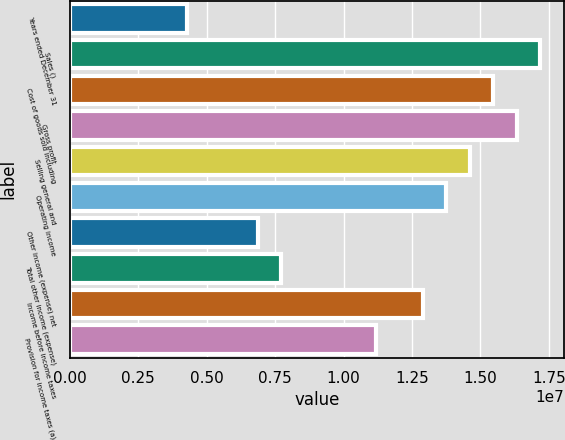<chart> <loc_0><loc_0><loc_500><loc_500><bar_chart><fcel>Years ended December 31<fcel>Sales ()<fcel>Cost of goods sold including<fcel>Gross profit<fcel>Selling general and<fcel>Operating income<fcel>Other income (expense) net<fcel>Total other income (expense)<fcel>Income before income taxes<fcel>Provision for income taxes (a)<nl><fcel>4.29655e+06<fcel>1.71862e+07<fcel>1.54676e+07<fcel>1.63269e+07<fcel>1.46083e+07<fcel>1.3749e+07<fcel>6.87448e+06<fcel>7.73379e+06<fcel>1.28896e+07<fcel>1.1171e+07<nl></chart> 